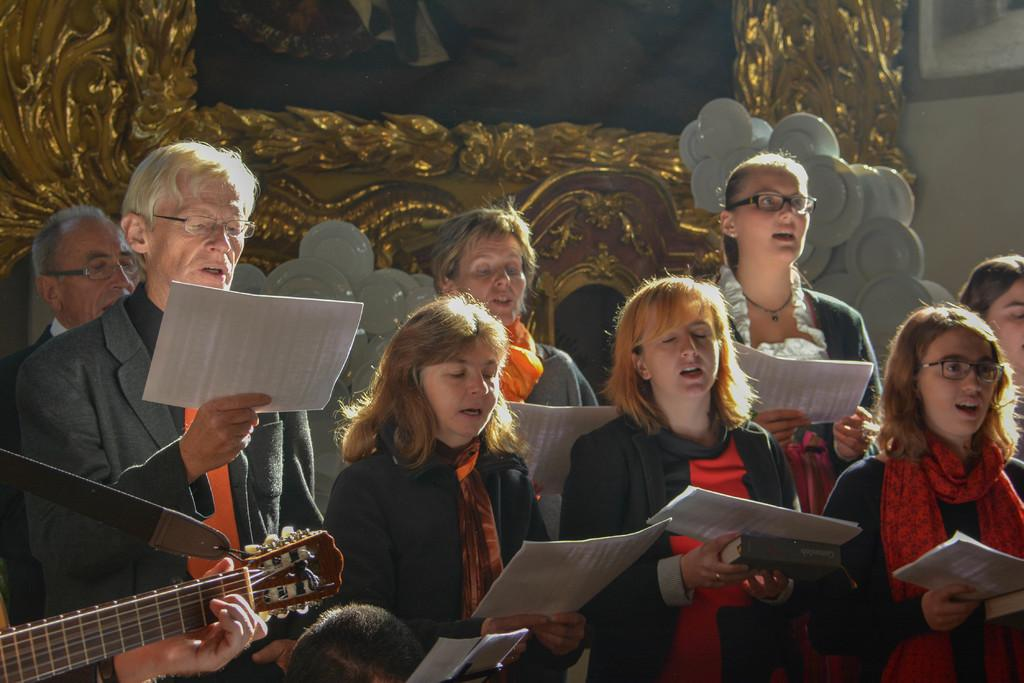How many people are in the image? There are persons standing in the image. What are the persons holding in their hands? The persons are holding a paper with their hands. What musical instrument can be seen in the image? There is a guitar in the image. What is the background of the image? There is a wall in the image. Is there an umbrella being used by the persons in the image? There is no umbrella present in the image. What level of difficulty is the game being played by the persons in the image? There is no game being played in the image, so there is no level of difficulty to consider. 